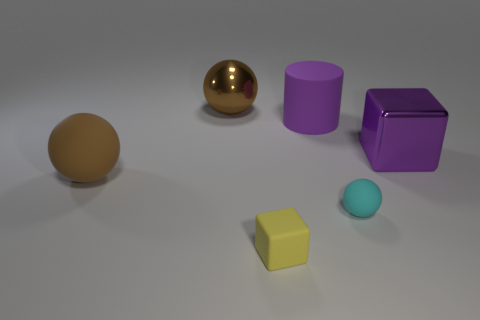Add 4 purple shiny cubes. How many objects exist? 10 Subtract all cubes. How many objects are left? 4 Add 3 big things. How many big things are left? 7 Add 4 yellow things. How many yellow things exist? 5 Subtract 0 cyan cylinders. How many objects are left? 6 Subtract all yellow rubber objects. Subtract all big purple shiny objects. How many objects are left? 4 